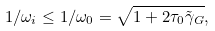<formula> <loc_0><loc_0><loc_500><loc_500>1 / \omega _ { i } \leq 1 / \omega _ { 0 } = \sqrt { 1 + 2 \tau _ { 0 } \tilde { \gamma } _ { G } } ,</formula> 